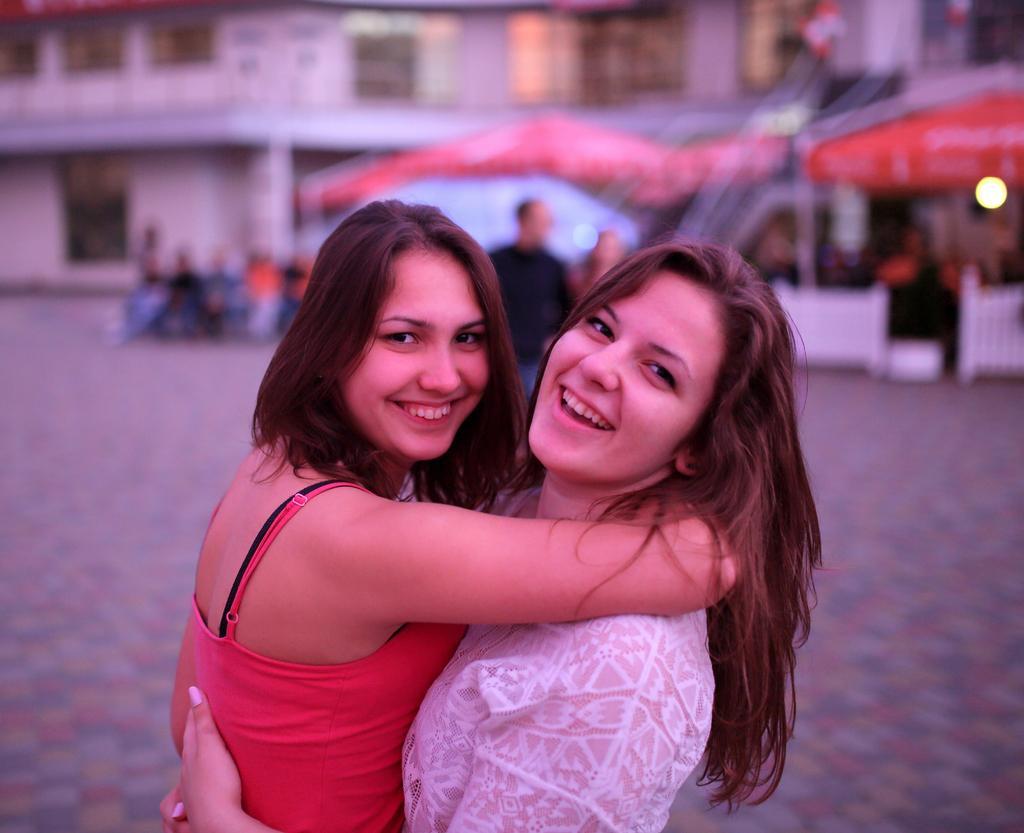In one or two sentences, can you explain what this image depicts? In the middle of this image, there are two women in different color dresses, smiling and hugging. In the background, there are persons, umbrellas and buildings. And the background is blurred. 